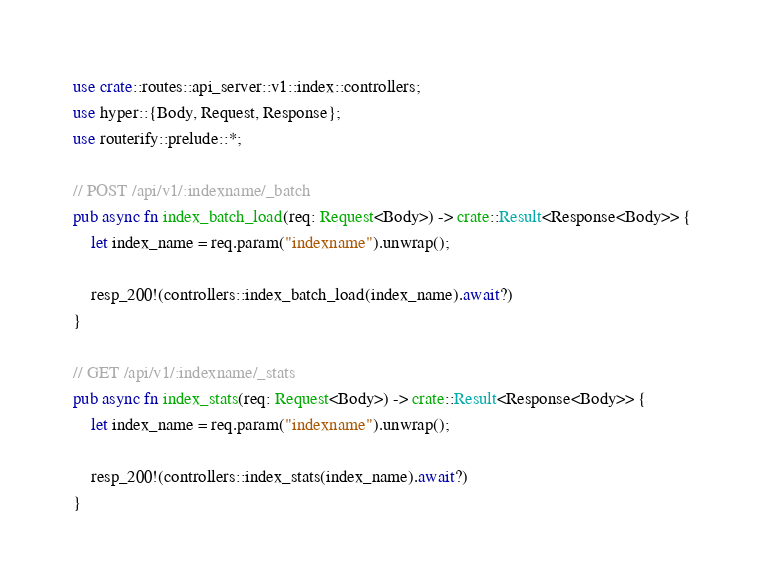Convert code to text. <code><loc_0><loc_0><loc_500><loc_500><_Rust_>use crate::routes::api_server::v1::index::controllers;
use hyper::{Body, Request, Response};
use routerify::prelude::*;

// POST /api/v1/:indexname/_batch
pub async fn index_batch_load(req: Request<Body>) -> crate::Result<Response<Body>> {
    let index_name = req.param("indexname").unwrap();

    resp_200!(controllers::index_batch_load(index_name).await?)
}

// GET /api/v1/:indexname/_stats
pub async fn index_stats(req: Request<Body>) -> crate::Result<Response<Body>> {
    let index_name = req.param("indexname").unwrap();

    resp_200!(controllers::index_stats(index_name).await?)
}
</code> 